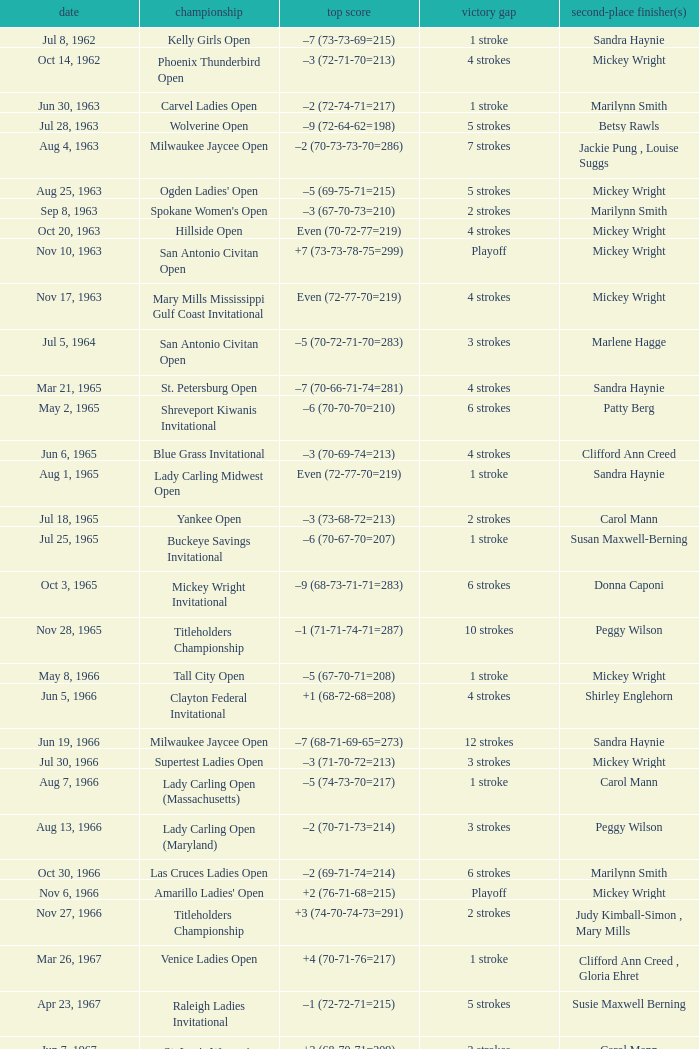What was the margin of victory on Apr 23, 1967? 5 strokes. 